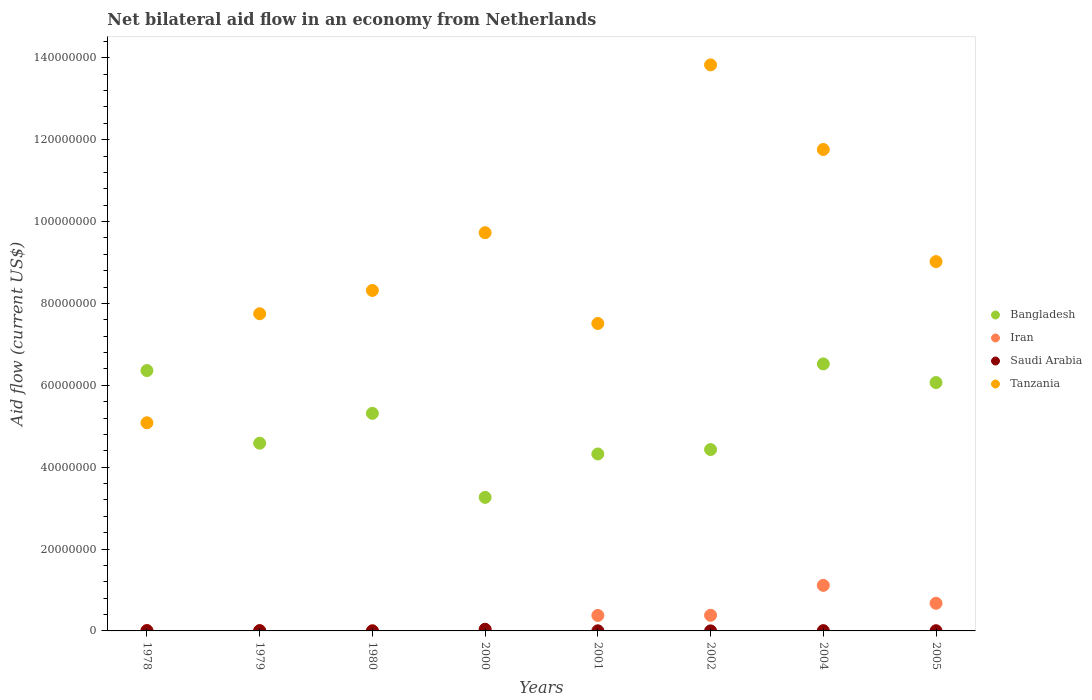How many different coloured dotlines are there?
Offer a very short reply. 4. What is the net bilateral aid flow in Bangladesh in 2002?
Provide a succinct answer. 4.43e+07. Across all years, what is the maximum net bilateral aid flow in Iran?
Make the answer very short. 1.11e+07. Across all years, what is the minimum net bilateral aid flow in Saudi Arabia?
Give a very brief answer. 10000. In which year was the net bilateral aid flow in Iran maximum?
Provide a short and direct response. 2004. In which year was the net bilateral aid flow in Tanzania minimum?
Provide a short and direct response. 1978. What is the total net bilateral aid flow in Bangladesh in the graph?
Provide a short and direct response. 4.09e+08. What is the difference between the net bilateral aid flow in Bangladesh in 1980 and that in 2002?
Offer a terse response. 8.85e+06. What is the difference between the net bilateral aid flow in Iran in 1979 and the net bilateral aid flow in Saudi Arabia in 1978?
Provide a succinct answer. -3.00e+04. What is the average net bilateral aid flow in Tanzania per year?
Your answer should be compact. 9.13e+07. In the year 2000, what is the difference between the net bilateral aid flow in Bangladesh and net bilateral aid flow in Tanzania?
Provide a succinct answer. -6.47e+07. What is the ratio of the net bilateral aid flow in Saudi Arabia in 1978 to that in 1980?
Provide a succinct answer. 3.5. Is the net bilateral aid flow in Bangladesh in 2000 less than that in 2004?
Your answer should be compact. Yes. Is the difference between the net bilateral aid flow in Bangladesh in 1979 and 1980 greater than the difference between the net bilateral aid flow in Tanzania in 1979 and 1980?
Provide a succinct answer. No. What is the difference between the highest and the second highest net bilateral aid flow in Saudi Arabia?
Provide a succinct answer. 3.40e+05. What is the difference between the highest and the lowest net bilateral aid flow in Bangladesh?
Offer a terse response. 3.26e+07. In how many years, is the net bilateral aid flow in Saudi Arabia greater than the average net bilateral aid flow in Saudi Arabia taken over all years?
Give a very brief answer. 1. Is it the case that in every year, the sum of the net bilateral aid flow in Iran and net bilateral aid flow in Tanzania  is greater than the sum of net bilateral aid flow in Bangladesh and net bilateral aid flow in Saudi Arabia?
Your response must be concise. No. Is it the case that in every year, the sum of the net bilateral aid flow in Bangladesh and net bilateral aid flow in Saudi Arabia  is greater than the net bilateral aid flow in Iran?
Keep it short and to the point. Yes. Does the net bilateral aid flow in Tanzania monotonically increase over the years?
Your answer should be compact. No. How many dotlines are there?
Keep it short and to the point. 4. How many years are there in the graph?
Offer a terse response. 8. Does the graph contain any zero values?
Your response must be concise. No. Does the graph contain grids?
Your answer should be very brief. No. How many legend labels are there?
Keep it short and to the point. 4. How are the legend labels stacked?
Offer a very short reply. Vertical. What is the title of the graph?
Your answer should be compact. Net bilateral aid flow in an economy from Netherlands. What is the label or title of the X-axis?
Offer a terse response. Years. What is the Aid flow (current US$) of Bangladesh in 1978?
Offer a very short reply. 6.36e+07. What is the Aid flow (current US$) of Saudi Arabia in 1978?
Make the answer very short. 7.00e+04. What is the Aid flow (current US$) of Tanzania in 1978?
Your answer should be very brief. 5.08e+07. What is the Aid flow (current US$) in Bangladesh in 1979?
Keep it short and to the point. 4.59e+07. What is the Aid flow (current US$) of Tanzania in 1979?
Ensure brevity in your answer.  7.75e+07. What is the Aid flow (current US$) of Bangladesh in 1980?
Your answer should be very brief. 5.32e+07. What is the Aid flow (current US$) of Iran in 1980?
Provide a succinct answer. 10000. What is the Aid flow (current US$) in Tanzania in 1980?
Make the answer very short. 8.32e+07. What is the Aid flow (current US$) in Bangladesh in 2000?
Your answer should be very brief. 3.26e+07. What is the Aid flow (current US$) of Saudi Arabia in 2000?
Provide a succinct answer. 4.10e+05. What is the Aid flow (current US$) in Tanzania in 2000?
Ensure brevity in your answer.  9.73e+07. What is the Aid flow (current US$) in Bangladesh in 2001?
Ensure brevity in your answer.  4.32e+07. What is the Aid flow (current US$) in Iran in 2001?
Give a very brief answer. 3.78e+06. What is the Aid flow (current US$) of Saudi Arabia in 2001?
Your response must be concise. 3.00e+04. What is the Aid flow (current US$) in Tanzania in 2001?
Make the answer very short. 7.51e+07. What is the Aid flow (current US$) in Bangladesh in 2002?
Keep it short and to the point. 4.43e+07. What is the Aid flow (current US$) in Iran in 2002?
Provide a short and direct response. 3.82e+06. What is the Aid flow (current US$) in Tanzania in 2002?
Give a very brief answer. 1.38e+08. What is the Aid flow (current US$) of Bangladesh in 2004?
Your answer should be compact. 6.52e+07. What is the Aid flow (current US$) in Iran in 2004?
Make the answer very short. 1.11e+07. What is the Aid flow (current US$) in Saudi Arabia in 2004?
Make the answer very short. 7.00e+04. What is the Aid flow (current US$) in Tanzania in 2004?
Your response must be concise. 1.18e+08. What is the Aid flow (current US$) in Bangladesh in 2005?
Provide a short and direct response. 6.07e+07. What is the Aid flow (current US$) of Iran in 2005?
Your response must be concise. 6.75e+06. What is the Aid flow (current US$) of Tanzania in 2005?
Offer a terse response. 9.02e+07. Across all years, what is the maximum Aid flow (current US$) in Bangladesh?
Offer a terse response. 6.52e+07. Across all years, what is the maximum Aid flow (current US$) in Iran?
Offer a terse response. 1.11e+07. Across all years, what is the maximum Aid flow (current US$) in Saudi Arabia?
Offer a terse response. 4.10e+05. Across all years, what is the maximum Aid flow (current US$) in Tanzania?
Keep it short and to the point. 1.38e+08. Across all years, what is the minimum Aid flow (current US$) of Bangladesh?
Your answer should be very brief. 3.26e+07. Across all years, what is the minimum Aid flow (current US$) of Iran?
Provide a short and direct response. 10000. Across all years, what is the minimum Aid flow (current US$) of Saudi Arabia?
Offer a very short reply. 10000. Across all years, what is the minimum Aid flow (current US$) of Tanzania?
Keep it short and to the point. 5.08e+07. What is the total Aid flow (current US$) in Bangladesh in the graph?
Provide a succinct answer. 4.09e+08. What is the total Aid flow (current US$) of Iran in the graph?
Your response must be concise. 2.57e+07. What is the total Aid flow (current US$) in Saudi Arabia in the graph?
Provide a succinct answer. 7.30e+05. What is the total Aid flow (current US$) in Tanzania in the graph?
Your answer should be very brief. 7.30e+08. What is the difference between the Aid flow (current US$) in Bangladesh in 1978 and that in 1979?
Your answer should be very brief. 1.78e+07. What is the difference between the Aid flow (current US$) in Saudi Arabia in 1978 and that in 1979?
Your answer should be very brief. 0. What is the difference between the Aid flow (current US$) in Tanzania in 1978 and that in 1979?
Offer a terse response. -2.66e+07. What is the difference between the Aid flow (current US$) in Bangladesh in 1978 and that in 1980?
Your response must be concise. 1.04e+07. What is the difference between the Aid flow (current US$) of Saudi Arabia in 1978 and that in 1980?
Make the answer very short. 5.00e+04. What is the difference between the Aid flow (current US$) in Tanzania in 1978 and that in 1980?
Provide a succinct answer. -3.23e+07. What is the difference between the Aid flow (current US$) in Bangladesh in 1978 and that in 2000?
Provide a succinct answer. 3.10e+07. What is the difference between the Aid flow (current US$) in Tanzania in 1978 and that in 2000?
Your response must be concise. -4.64e+07. What is the difference between the Aid flow (current US$) in Bangladesh in 1978 and that in 2001?
Your response must be concise. 2.04e+07. What is the difference between the Aid flow (current US$) in Iran in 1978 and that in 2001?
Offer a very short reply. -3.71e+06. What is the difference between the Aid flow (current US$) of Saudi Arabia in 1978 and that in 2001?
Offer a terse response. 4.00e+04. What is the difference between the Aid flow (current US$) of Tanzania in 1978 and that in 2001?
Offer a very short reply. -2.43e+07. What is the difference between the Aid flow (current US$) of Bangladesh in 1978 and that in 2002?
Your response must be concise. 1.93e+07. What is the difference between the Aid flow (current US$) of Iran in 1978 and that in 2002?
Make the answer very short. -3.75e+06. What is the difference between the Aid flow (current US$) of Saudi Arabia in 1978 and that in 2002?
Provide a short and direct response. 6.00e+04. What is the difference between the Aid flow (current US$) in Tanzania in 1978 and that in 2002?
Provide a succinct answer. -8.74e+07. What is the difference between the Aid flow (current US$) of Bangladesh in 1978 and that in 2004?
Your answer should be very brief. -1.62e+06. What is the difference between the Aid flow (current US$) in Iran in 1978 and that in 2004?
Give a very brief answer. -1.11e+07. What is the difference between the Aid flow (current US$) in Tanzania in 1978 and that in 2004?
Your response must be concise. -6.68e+07. What is the difference between the Aid flow (current US$) of Bangladesh in 1978 and that in 2005?
Provide a succinct answer. 2.93e+06. What is the difference between the Aid flow (current US$) in Iran in 1978 and that in 2005?
Provide a short and direct response. -6.68e+06. What is the difference between the Aid flow (current US$) in Tanzania in 1978 and that in 2005?
Give a very brief answer. -3.94e+07. What is the difference between the Aid flow (current US$) in Bangladesh in 1979 and that in 1980?
Your answer should be compact. -7.30e+06. What is the difference between the Aid flow (current US$) in Tanzania in 1979 and that in 1980?
Offer a very short reply. -5.69e+06. What is the difference between the Aid flow (current US$) in Bangladesh in 1979 and that in 2000?
Your response must be concise. 1.32e+07. What is the difference between the Aid flow (current US$) of Iran in 1979 and that in 2000?
Your answer should be very brief. -3.00e+04. What is the difference between the Aid flow (current US$) in Saudi Arabia in 1979 and that in 2000?
Your response must be concise. -3.40e+05. What is the difference between the Aid flow (current US$) of Tanzania in 1979 and that in 2000?
Ensure brevity in your answer.  -1.98e+07. What is the difference between the Aid flow (current US$) in Bangladesh in 1979 and that in 2001?
Provide a short and direct response. 2.63e+06. What is the difference between the Aid flow (current US$) of Iran in 1979 and that in 2001?
Offer a very short reply. -3.74e+06. What is the difference between the Aid flow (current US$) in Tanzania in 1979 and that in 2001?
Ensure brevity in your answer.  2.38e+06. What is the difference between the Aid flow (current US$) of Bangladesh in 1979 and that in 2002?
Offer a very short reply. 1.55e+06. What is the difference between the Aid flow (current US$) in Iran in 1979 and that in 2002?
Your answer should be very brief. -3.78e+06. What is the difference between the Aid flow (current US$) of Tanzania in 1979 and that in 2002?
Your response must be concise. -6.08e+07. What is the difference between the Aid flow (current US$) in Bangladesh in 1979 and that in 2004?
Keep it short and to the point. -1.94e+07. What is the difference between the Aid flow (current US$) of Iran in 1979 and that in 2004?
Your response must be concise. -1.11e+07. What is the difference between the Aid flow (current US$) in Tanzania in 1979 and that in 2004?
Your answer should be compact. -4.01e+07. What is the difference between the Aid flow (current US$) of Bangladesh in 1979 and that in 2005?
Provide a succinct answer. -1.48e+07. What is the difference between the Aid flow (current US$) in Iran in 1979 and that in 2005?
Make the answer very short. -6.71e+06. What is the difference between the Aid flow (current US$) of Tanzania in 1979 and that in 2005?
Your response must be concise. -1.27e+07. What is the difference between the Aid flow (current US$) in Bangladesh in 1980 and that in 2000?
Your answer should be compact. 2.05e+07. What is the difference between the Aid flow (current US$) of Iran in 1980 and that in 2000?
Your response must be concise. -6.00e+04. What is the difference between the Aid flow (current US$) in Saudi Arabia in 1980 and that in 2000?
Provide a succinct answer. -3.90e+05. What is the difference between the Aid flow (current US$) in Tanzania in 1980 and that in 2000?
Provide a short and direct response. -1.41e+07. What is the difference between the Aid flow (current US$) of Bangladesh in 1980 and that in 2001?
Offer a terse response. 9.93e+06. What is the difference between the Aid flow (current US$) of Iran in 1980 and that in 2001?
Your response must be concise. -3.77e+06. What is the difference between the Aid flow (current US$) in Tanzania in 1980 and that in 2001?
Give a very brief answer. 8.07e+06. What is the difference between the Aid flow (current US$) of Bangladesh in 1980 and that in 2002?
Ensure brevity in your answer.  8.85e+06. What is the difference between the Aid flow (current US$) of Iran in 1980 and that in 2002?
Your answer should be compact. -3.81e+06. What is the difference between the Aid flow (current US$) in Tanzania in 1980 and that in 2002?
Make the answer very short. -5.51e+07. What is the difference between the Aid flow (current US$) of Bangladesh in 1980 and that in 2004?
Provide a succinct answer. -1.21e+07. What is the difference between the Aid flow (current US$) of Iran in 1980 and that in 2004?
Offer a very short reply. -1.11e+07. What is the difference between the Aid flow (current US$) of Saudi Arabia in 1980 and that in 2004?
Your answer should be compact. -5.00e+04. What is the difference between the Aid flow (current US$) in Tanzania in 1980 and that in 2004?
Provide a short and direct response. -3.44e+07. What is the difference between the Aid flow (current US$) of Bangladesh in 1980 and that in 2005?
Offer a terse response. -7.52e+06. What is the difference between the Aid flow (current US$) of Iran in 1980 and that in 2005?
Offer a very short reply. -6.74e+06. What is the difference between the Aid flow (current US$) in Saudi Arabia in 1980 and that in 2005?
Offer a terse response. -3.00e+04. What is the difference between the Aid flow (current US$) in Tanzania in 1980 and that in 2005?
Your answer should be compact. -7.05e+06. What is the difference between the Aid flow (current US$) of Bangladesh in 2000 and that in 2001?
Offer a terse response. -1.06e+07. What is the difference between the Aid flow (current US$) of Iran in 2000 and that in 2001?
Your response must be concise. -3.71e+06. What is the difference between the Aid flow (current US$) in Tanzania in 2000 and that in 2001?
Your answer should be very brief. 2.22e+07. What is the difference between the Aid flow (current US$) of Bangladesh in 2000 and that in 2002?
Your answer should be compact. -1.17e+07. What is the difference between the Aid flow (current US$) of Iran in 2000 and that in 2002?
Make the answer very short. -3.75e+06. What is the difference between the Aid flow (current US$) of Saudi Arabia in 2000 and that in 2002?
Your answer should be very brief. 4.00e+05. What is the difference between the Aid flow (current US$) of Tanzania in 2000 and that in 2002?
Ensure brevity in your answer.  -4.10e+07. What is the difference between the Aid flow (current US$) of Bangladesh in 2000 and that in 2004?
Keep it short and to the point. -3.26e+07. What is the difference between the Aid flow (current US$) in Iran in 2000 and that in 2004?
Ensure brevity in your answer.  -1.11e+07. What is the difference between the Aid flow (current US$) of Saudi Arabia in 2000 and that in 2004?
Provide a succinct answer. 3.40e+05. What is the difference between the Aid flow (current US$) of Tanzania in 2000 and that in 2004?
Provide a succinct answer. -2.03e+07. What is the difference between the Aid flow (current US$) in Bangladesh in 2000 and that in 2005?
Offer a very short reply. -2.80e+07. What is the difference between the Aid flow (current US$) in Iran in 2000 and that in 2005?
Your response must be concise. -6.68e+06. What is the difference between the Aid flow (current US$) in Saudi Arabia in 2000 and that in 2005?
Give a very brief answer. 3.60e+05. What is the difference between the Aid flow (current US$) in Tanzania in 2000 and that in 2005?
Ensure brevity in your answer.  7.06e+06. What is the difference between the Aid flow (current US$) in Bangladesh in 2001 and that in 2002?
Your answer should be very brief. -1.08e+06. What is the difference between the Aid flow (current US$) of Tanzania in 2001 and that in 2002?
Ensure brevity in your answer.  -6.32e+07. What is the difference between the Aid flow (current US$) of Bangladesh in 2001 and that in 2004?
Make the answer very short. -2.20e+07. What is the difference between the Aid flow (current US$) of Iran in 2001 and that in 2004?
Keep it short and to the point. -7.35e+06. What is the difference between the Aid flow (current US$) of Tanzania in 2001 and that in 2004?
Make the answer very short. -4.25e+07. What is the difference between the Aid flow (current US$) in Bangladesh in 2001 and that in 2005?
Your response must be concise. -1.74e+07. What is the difference between the Aid flow (current US$) of Iran in 2001 and that in 2005?
Keep it short and to the point. -2.97e+06. What is the difference between the Aid flow (current US$) in Saudi Arabia in 2001 and that in 2005?
Offer a very short reply. -2.00e+04. What is the difference between the Aid flow (current US$) of Tanzania in 2001 and that in 2005?
Your answer should be very brief. -1.51e+07. What is the difference between the Aid flow (current US$) in Bangladesh in 2002 and that in 2004?
Make the answer very short. -2.09e+07. What is the difference between the Aid flow (current US$) of Iran in 2002 and that in 2004?
Your answer should be compact. -7.31e+06. What is the difference between the Aid flow (current US$) of Saudi Arabia in 2002 and that in 2004?
Ensure brevity in your answer.  -6.00e+04. What is the difference between the Aid flow (current US$) of Tanzania in 2002 and that in 2004?
Provide a short and direct response. 2.07e+07. What is the difference between the Aid flow (current US$) of Bangladesh in 2002 and that in 2005?
Your answer should be very brief. -1.64e+07. What is the difference between the Aid flow (current US$) of Iran in 2002 and that in 2005?
Give a very brief answer. -2.93e+06. What is the difference between the Aid flow (current US$) in Tanzania in 2002 and that in 2005?
Your answer should be compact. 4.81e+07. What is the difference between the Aid flow (current US$) in Bangladesh in 2004 and that in 2005?
Your answer should be compact. 4.55e+06. What is the difference between the Aid flow (current US$) of Iran in 2004 and that in 2005?
Your response must be concise. 4.38e+06. What is the difference between the Aid flow (current US$) of Tanzania in 2004 and that in 2005?
Make the answer very short. 2.74e+07. What is the difference between the Aid flow (current US$) of Bangladesh in 1978 and the Aid flow (current US$) of Iran in 1979?
Offer a terse response. 6.36e+07. What is the difference between the Aid flow (current US$) in Bangladesh in 1978 and the Aid flow (current US$) in Saudi Arabia in 1979?
Your answer should be compact. 6.35e+07. What is the difference between the Aid flow (current US$) of Bangladesh in 1978 and the Aid flow (current US$) of Tanzania in 1979?
Make the answer very short. -1.39e+07. What is the difference between the Aid flow (current US$) of Iran in 1978 and the Aid flow (current US$) of Tanzania in 1979?
Your answer should be compact. -7.74e+07. What is the difference between the Aid flow (current US$) of Saudi Arabia in 1978 and the Aid flow (current US$) of Tanzania in 1979?
Offer a very short reply. -7.74e+07. What is the difference between the Aid flow (current US$) in Bangladesh in 1978 and the Aid flow (current US$) in Iran in 1980?
Give a very brief answer. 6.36e+07. What is the difference between the Aid flow (current US$) in Bangladesh in 1978 and the Aid flow (current US$) in Saudi Arabia in 1980?
Provide a short and direct response. 6.36e+07. What is the difference between the Aid flow (current US$) in Bangladesh in 1978 and the Aid flow (current US$) in Tanzania in 1980?
Your answer should be very brief. -1.96e+07. What is the difference between the Aid flow (current US$) of Iran in 1978 and the Aid flow (current US$) of Tanzania in 1980?
Provide a succinct answer. -8.31e+07. What is the difference between the Aid flow (current US$) in Saudi Arabia in 1978 and the Aid flow (current US$) in Tanzania in 1980?
Make the answer very short. -8.31e+07. What is the difference between the Aid flow (current US$) in Bangladesh in 1978 and the Aid flow (current US$) in Iran in 2000?
Keep it short and to the point. 6.35e+07. What is the difference between the Aid flow (current US$) in Bangladesh in 1978 and the Aid flow (current US$) in Saudi Arabia in 2000?
Ensure brevity in your answer.  6.32e+07. What is the difference between the Aid flow (current US$) in Bangladesh in 1978 and the Aid flow (current US$) in Tanzania in 2000?
Your answer should be compact. -3.37e+07. What is the difference between the Aid flow (current US$) of Iran in 1978 and the Aid flow (current US$) of Tanzania in 2000?
Your answer should be compact. -9.72e+07. What is the difference between the Aid flow (current US$) in Saudi Arabia in 1978 and the Aid flow (current US$) in Tanzania in 2000?
Offer a very short reply. -9.72e+07. What is the difference between the Aid flow (current US$) of Bangladesh in 1978 and the Aid flow (current US$) of Iran in 2001?
Ensure brevity in your answer.  5.98e+07. What is the difference between the Aid flow (current US$) of Bangladesh in 1978 and the Aid flow (current US$) of Saudi Arabia in 2001?
Make the answer very short. 6.36e+07. What is the difference between the Aid flow (current US$) in Bangladesh in 1978 and the Aid flow (current US$) in Tanzania in 2001?
Offer a very short reply. -1.15e+07. What is the difference between the Aid flow (current US$) in Iran in 1978 and the Aid flow (current US$) in Tanzania in 2001?
Give a very brief answer. -7.50e+07. What is the difference between the Aid flow (current US$) in Saudi Arabia in 1978 and the Aid flow (current US$) in Tanzania in 2001?
Your answer should be compact. -7.50e+07. What is the difference between the Aid flow (current US$) in Bangladesh in 1978 and the Aid flow (current US$) in Iran in 2002?
Make the answer very short. 5.98e+07. What is the difference between the Aid flow (current US$) in Bangladesh in 1978 and the Aid flow (current US$) in Saudi Arabia in 2002?
Give a very brief answer. 6.36e+07. What is the difference between the Aid flow (current US$) of Bangladesh in 1978 and the Aid flow (current US$) of Tanzania in 2002?
Ensure brevity in your answer.  -7.47e+07. What is the difference between the Aid flow (current US$) in Iran in 1978 and the Aid flow (current US$) in Saudi Arabia in 2002?
Give a very brief answer. 6.00e+04. What is the difference between the Aid flow (current US$) in Iran in 1978 and the Aid flow (current US$) in Tanzania in 2002?
Keep it short and to the point. -1.38e+08. What is the difference between the Aid flow (current US$) in Saudi Arabia in 1978 and the Aid flow (current US$) in Tanzania in 2002?
Provide a succinct answer. -1.38e+08. What is the difference between the Aid flow (current US$) of Bangladesh in 1978 and the Aid flow (current US$) of Iran in 2004?
Keep it short and to the point. 5.25e+07. What is the difference between the Aid flow (current US$) in Bangladesh in 1978 and the Aid flow (current US$) in Saudi Arabia in 2004?
Keep it short and to the point. 6.35e+07. What is the difference between the Aid flow (current US$) of Bangladesh in 1978 and the Aid flow (current US$) of Tanzania in 2004?
Keep it short and to the point. -5.40e+07. What is the difference between the Aid flow (current US$) of Iran in 1978 and the Aid flow (current US$) of Saudi Arabia in 2004?
Your answer should be very brief. 0. What is the difference between the Aid flow (current US$) in Iran in 1978 and the Aid flow (current US$) in Tanzania in 2004?
Your answer should be very brief. -1.18e+08. What is the difference between the Aid flow (current US$) of Saudi Arabia in 1978 and the Aid flow (current US$) of Tanzania in 2004?
Give a very brief answer. -1.18e+08. What is the difference between the Aid flow (current US$) in Bangladesh in 1978 and the Aid flow (current US$) in Iran in 2005?
Give a very brief answer. 5.69e+07. What is the difference between the Aid flow (current US$) in Bangladesh in 1978 and the Aid flow (current US$) in Saudi Arabia in 2005?
Provide a succinct answer. 6.36e+07. What is the difference between the Aid flow (current US$) in Bangladesh in 1978 and the Aid flow (current US$) in Tanzania in 2005?
Offer a very short reply. -2.66e+07. What is the difference between the Aid flow (current US$) in Iran in 1978 and the Aid flow (current US$) in Tanzania in 2005?
Offer a very short reply. -9.02e+07. What is the difference between the Aid flow (current US$) in Saudi Arabia in 1978 and the Aid flow (current US$) in Tanzania in 2005?
Provide a succinct answer. -9.02e+07. What is the difference between the Aid flow (current US$) of Bangladesh in 1979 and the Aid flow (current US$) of Iran in 1980?
Provide a succinct answer. 4.58e+07. What is the difference between the Aid flow (current US$) in Bangladesh in 1979 and the Aid flow (current US$) in Saudi Arabia in 1980?
Offer a terse response. 4.58e+07. What is the difference between the Aid flow (current US$) of Bangladesh in 1979 and the Aid flow (current US$) of Tanzania in 1980?
Give a very brief answer. -3.73e+07. What is the difference between the Aid flow (current US$) in Iran in 1979 and the Aid flow (current US$) in Tanzania in 1980?
Offer a very short reply. -8.31e+07. What is the difference between the Aid flow (current US$) in Saudi Arabia in 1979 and the Aid flow (current US$) in Tanzania in 1980?
Your answer should be compact. -8.31e+07. What is the difference between the Aid flow (current US$) of Bangladesh in 1979 and the Aid flow (current US$) of Iran in 2000?
Your answer should be compact. 4.58e+07. What is the difference between the Aid flow (current US$) in Bangladesh in 1979 and the Aid flow (current US$) in Saudi Arabia in 2000?
Provide a succinct answer. 4.54e+07. What is the difference between the Aid flow (current US$) of Bangladesh in 1979 and the Aid flow (current US$) of Tanzania in 2000?
Ensure brevity in your answer.  -5.14e+07. What is the difference between the Aid flow (current US$) in Iran in 1979 and the Aid flow (current US$) in Saudi Arabia in 2000?
Provide a succinct answer. -3.70e+05. What is the difference between the Aid flow (current US$) in Iran in 1979 and the Aid flow (current US$) in Tanzania in 2000?
Your answer should be compact. -9.72e+07. What is the difference between the Aid flow (current US$) in Saudi Arabia in 1979 and the Aid flow (current US$) in Tanzania in 2000?
Ensure brevity in your answer.  -9.72e+07. What is the difference between the Aid flow (current US$) of Bangladesh in 1979 and the Aid flow (current US$) of Iran in 2001?
Offer a terse response. 4.21e+07. What is the difference between the Aid flow (current US$) in Bangladesh in 1979 and the Aid flow (current US$) in Saudi Arabia in 2001?
Your response must be concise. 4.58e+07. What is the difference between the Aid flow (current US$) in Bangladesh in 1979 and the Aid flow (current US$) in Tanzania in 2001?
Give a very brief answer. -2.92e+07. What is the difference between the Aid flow (current US$) in Iran in 1979 and the Aid flow (current US$) in Tanzania in 2001?
Provide a succinct answer. -7.51e+07. What is the difference between the Aid flow (current US$) of Saudi Arabia in 1979 and the Aid flow (current US$) of Tanzania in 2001?
Keep it short and to the point. -7.50e+07. What is the difference between the Aid flow (current US$) in Bangladesh in 1979 and the Aid flow (current US$) in Iran in 2002?
Make the answer very short. 4.20e+07. What is the difference between the Aid flow (current US$) in Bangladesh in 1979 and the Aid flow (current US$) in Saudi Arabia in 2002?
Provide a succinct answer. 4.58e+07. What is the difference between the Aid flow (current US$) in Bangladesh in 1979 and the Aid flow (current US$) in Tanzania in 2002?
Offer a very short reply. -9.24e+07. What is the difference between the Aid flow (current US$) in Iran in 1979 and the Aid flow (current US$) in Tanzania in 2002?
Keep it short and to the point. -1.38e+08. What is the difference between the Aid flow (current US$) of Saudi Arabia in 1979 and the Aid flow (current US$) of Tanzania in 2002?
Your answer should be compact. -1.38e+08. What is the difference between the Aid flow (current US$) in Bangladesh in 1979 and the Aid flow (current US$) in Iran in 2004?
Make the answer very short. 3.47e+07. What is the difference between the Aid flow (current US$) in Bangladesh in 1979 and the Aid flow (current US$) in Saudi Arabia in 2004?
Keep it short and to the point. 4.58e+07. What is the difference between the Aid flow (current US$) in Bangladesh in 1979 and the Aid flow (current US$) in Tanzania in 2004?
Your answer should be compact. -7.18e+07. What is the difference between the Aid flow (current US$) in Iran in 1979 and the Aid flow (current US$) in Saudi Arabia in 2004?
Provide a succinct answer. -3.00e+04. What is the difference between the Aid flow (current US$) in Iran in 1979 and the Aid flow (current US$) in Tanzania in 2004?
Keep it short and to the point. -1.18e+08. What is the difference between the Aid flow (current US$) in Saudi Arabia in 1979 and the Aid flow (current US$) in Tanzania in 2004?
Your response must be concise. -1.18e+08. What is the difference between the Aid flow (current US$) in Bangladesh in 1979 and the Aid flow (current US$) in Iran in 2005?
Your answer should be very brief. 3.91e+07. What is the difference between the Aid flow (current US$) in Bangladesh in 1979 and the Aid flow (current US$) in Saudi Arabia in 2005?
Your answer should be very brief. 4.58e+07. What is the difference between the Aid flow (current US$) in Bangladesh in 1979 and the Aid flow (current US$) in Tanzania in 2005?
Ensure brevity in your answer.  -4.44e+07. What is the difference between the Aid flow (current US$) of Iran in 1979 and the Aid flow (current US$) of Tanzania in 2005?
Keep it short and to the point. -9.02e+07. What is the difference between the Aid flow (current US$) in Saudi Arabia in 1979 and the Aid flow (current US$) in Tanzania in 2005?
Make the answer very short. -9.02e+07. What is the difference between the Aid flow (current US$) of Bangladesh in 1980 and the Aid flow (current US$) of Iran in 2000?
Your answer should be compact. 5.31e+07. What is the difference between the Aid flow (current US$) in Bangladesh in 1980 and the Aid flow (current US$) in Saudi Arabia in 2000?
Your answer should be compact. 5.28e+07. What is the difference between the Aid flow (current US$) of Bangladesh in 1980 and the Aid flow (current US$) of Tanzania in 2000?
Give a very brief answer. -4.41e+07. What is the difference between the Aid flow (current US$) in Iran in 1980 and the Aid flow (current US$) in Saudi Arabia in 2000?
Ensure brevity in your answer.  -4.00e+05. What is the difference between the Aid flow (current US$) in Iran in 1980 and the Aid flow (current US$) in Tanzania in 2000?
Your response must be concise. -9.73e+07. What is the difference between the Aid flow (current US$) of Saudi Arabia in 1980 and the Aid flow (current US$) of Tanzania in 2000?
Your response must be concise. -9.73e+07. What is the difference between the Aid flow (current US$) of Bangladesh in 1980 and the Aid flow (current US$) of Iran in 2001?
Ensure brevity in your answer.  4.94e+07. What is the difference between the Aid flow (current US$) of Bangladesh in 1980 and the Aid flow (current US$) of Saudi Arabia in 2001?
Your response must be concise. 5.31e+07. What is the difference between the Aid flow (current US$) of Bangladesh in 1980 and the Aid flow (current US$) of Tanzania in 2001?
Your answer should be compact. -2.20e+07. What is the difference between the Aid flow (current US$) in Iran in 1980 and the Aid flow (current US$) in Tanzania in 2001?
Provide a short and direct response. -7.51e+07. What is the difference between the Aid flow (current US$) of Saudi Arabia in 1980 and the Aid flow (current US$) of Tanzania in 2001?
Your answer should be compact. -7.51e+07. What is the difference between the Aid flow (current US$) in Bangladesh in 1980 and the Aid flow (current US$) in Iran in 2002?
Make the answer very short. 4.93e+07. What is the difference between the Aid flow (current US$) of Bangladesh in 1980 and the Aid flow (current US$) of Saudi Arabia in 2002?
Ensure brevity in your answer.  5.32e+07. What is the difference between the Aid flow (current US$) of Bangladesh in 1980 and the Aid flow (current US$) of Tanzania in 2002?
Offer a terse response. -8.51e+07. What is the difference between the Aid flow (current US$) of Iran in 1980 and the Aid flow (current US$) of Tanzania in 2002?
Keep it short and to the point. -1.38e+08. What is the difference between the Aid flow (current US$) in Saudi Arabia in 1980 and the Aid flow (current US$) in Tanzania in 2002?
Ensure brevity in your answer.  -1.38e+08. What is the difference between the Aid flow (current US$) in Bangladesh in 1980 and the Aid flow (current US$) in Iran in 2004?
Give a very brief answer. 4.20e+07. What is the difference between the Aid flow (current US$) in Bangladesh in 1980 and the Aid flow (current US$) in Saudi Arabia in 2004?
Provide a succinct answer. 5.31e+07. What is the difference between the Aid flow (current US$) in Bangladesh in 1980 and the Aid flow (current US$) in Tanzania in 2004?
Offer a terse response. -6.45e+07. What is the difference between the Aid flow (current US$) in Iran in 1980 and the Aid flow (current US$) in Saudi Arabia in 2004?
Provide a short and direct response. -6.00e+04. What is the difference between the Aid flow (current US$) in Iran in 1980 and the Aid flow (current US$) in Tanzania in 2004?
Your response must be concise. -1.18e+08. What is the difference between the Aid flow (current US$) in Saudi Arabia in 1980 and the Aid flow (current US$) in Tanzania in 2004?
Give a very brief answer. -1.18e+08. What is the difference between the Aid flow (current US$) of Bangladesh in 1980 and the Aid flow (current US$) of Iran in 2005?
Your answer should be compact. 4.64e+07. What is the difference between the Aid flow (current US$) of Bangladesh in 1980 and the Aid flow (current US$) of Saudi Arabia in 2005?
Offer a very short reply. 5.31e+07. What is the difference between the Aid flow (current US$) in Bangladesh in 1980 and the Aid flow (current US$) in Tanzania in 2005?
Provide a short and direct response. -3.71e+07. What is the difference between the Aid flow (current US$) in Iran in 1980 and the Aid flow (current US$) in Saudi Arabia in 2005?
Provide a short and direct response. -4.00e+04. What is the difference between the Aid flow (current US$) of Iran in 1980 and the Aid flow (current US$) of Tanzania in 2005?
Offer a terse response. -9.02e+07. What is the difference between the Aid flow (current US$) of Saudi Arabia in 1980 and the Aid flow (current US$) of Tanzania in 2005?
Offer a terse response. -9.02e+07. What is the difference between the Aid flow (current US$) of Bangladesh in 2000 and the Aid flow (current US$) of Iran in 2001?
Offer a very short reply. 2.88e+07. What is the difference between the Aid flow (current US$) of Bangladesh in 2000 and the Aid flow (current US$) of Saudi Arabia in 2001?
Ensure brevity in your answer.  3.26e+07. What is the difference between the Aid flow (current US$) in Bangladesh in 2000 and the Aid flow (current US$) in Tanzania in 2001?
Give a very brief answer. -4.25e+07. What is the difference between the Aid flow (current US$) in Iran in 2000 and the Aid flow (current US$) in Tanzania in 2001?
Offer a very short reply. -7.50e+07. What is the difference between the Aid flow (current US$) in Saudi Arabia in 2000 and the Aid flow (current US$) in Tanzania in 2001?
Give a very brief answer. -7.47e+07. What is the difference between the Aid flow (current US$) in Bangladesh in 2000 and the Aid flow (current US$) in Iran in 2002?
Your answer should be compact. 2.88e+07. What is the difference between the Aid flow (current US$) in Bangladesh in 2000 and the Aid flow (current US$) in Saudi Arabia in 2002?
Offer a terse response. 3.26e+07. What is the difference between the Aid flow (current US$) of Bangladesh in 2000 and the Aid flow (current US$) of Tanzania in 2002?
Keep it short and to the point. -1.06e+08. What is the difference between the Aid flow (current US$) of Iran in 2000 and the Aid flow (current US$) of Saudi Arabia in 2002?
Give a very brief answer. 6.00e+04. What is the difference between the Aid flow (current US$) of Iran in 2000 and the Aid flow (current US$) of Tanzania in 2002?
Offer a terse response. -1.38e+08. What is the difference between the Aid flow (current US$) of Saudi Arabia in 2000 and the Aid flow (current US$) of Tanzania in 2002?
Make the answer very short. -1.38e+08. What is the difference between the Aid flow (current US$) of Bangladesh in 2000 and the Aid flow (current US$) of Iran in 2004?
Ensure brevity in your answer.  2.15e+07. What is the difference between the Aid flow (current US$) of Bangladesh in 2000 and the Aid flow (current US$) of Saudi Arabia in 2004?
Provide a short and direct response. 3.26e+07. What is the difference between the Aid flow (current US$) in Bangladesh in 2000 and the Aid flow (current US$) in Tanzania in 2004?
Your answer should be very brief. -8.50e+07. What is the difference between the Aid flow (current US$) in Iran in 2000 and the Aid flow (current US$) in Saudi Arabia in 2004?
Give a very brief answer. 0. What is the difference between the Aid flow (current US$) in Iran in 2000 and the Aid flow (current US$) in Tanzania in 2004?
Your response must be concise. -1.18e+08. What is the difference between the Aid flow (current US$) in Saudi Arabia in 2000 and the Aid flow (current US$) in Tanzania in 2004?
Give a very brief answer. -1.17e+08. What is the difference between the Aid flow (current US$) in Bangladesh in 2000 and the Aid flow (current US$) in Iran in 2005?
Keep it short and to the point. 2.59e+07. What is the difference between the Aid flow (current US$) of Bangladesh in 2000 and the Aid flow (current US$) of Saudi Arabia in 2005?
Provide a short and direct response. 3.26e+07. What is the difference between the Aid flow (current US$) in Bangladesh in 2000 and the Aid flow (current US$) in Tanzania in 2005?
Make the answer very short. -5.76e+07. What is the difference between the Aid flow (current US$) of Iran in 2000 and the Aid flow (current US$) of Saudi Arabia in 2005?
Give a very brief answer. 2.00e+04. What is the difference between the Aid flow (current US$) in Iran in 2000 and the Aid flow (current US$) in Tanzania in 2005?
Offer a very short reply. -9.02e+07. What is the difference between the Aid flow (current US$) in Saudi Arabia in 2000 and the Aid flow (current US$) in Tanzania in 2005?
Make the answer very short. -8.98e+07. What is the difference between the Aid flow (current US$) in Bangladesh in 2001 and the Aid flow (current US$) in Iran in 2002?
Your answer should be compact. 3.94e+07. What is the difference between the Aid flow (current US$) in Bangladesh in 2001 and the Aid flow (current US$) in Saudi Arabia in 2002?
Offer a terse response. 4.32e+07. What is the difference between the Aid flow (current US$) of Bangladesh in 2001 and the Aid flow (current US$) of Tanzania in 2002?
Your response must be concise. -9.51e+07. What is the difference between the Aid flow (current US$) in Iran in 2001 and the Aid flow (current US$) in Saudi Arabia in 2002?
Give a very brief answer. 3.77e+06. What is the difference between the Aid flow (current US$) in Iran in 2001 and the Aid flow (current US$) in Tanzania in 2002?
Your answer should be very brief. -1.35e+08. What is the difference between the Aid flow (current US$) of Saudi Arabia in 2001 and the Aid flow (current US$) of Tanzania in 2002?
Provide a short and direct response. -1.38e+08. What is the difference between the Aid flow (current US$) in Bangladesh in 2001 and the Aid flow (current US$) in Iran in 2004?
Your answer should be very brief. 3.21e+07. What is the difference between the Aid flow (current US$) of Bangladesh in 2001 and the Aid flow (current US$) of Saudi Arabia in 2004?
Make the answer very short. 4.32e+07. What is the difference between the Aid flow (current US$) of Bangladesh in 2001 and the Aid flow (current US$) of Tanzania in 2004?
Make the answer very short. -7.44e+07. What is the difference between the Aid flow (current US$) of Iran in 2001 and the Aid flow (current US$) of Saudi Arabia in 2004?
Offer a terse response. 3.71e+06. What is the difference between the Aid flow (current US$) of Iran in 2001 and the Aid flow (current US$) of Tanzania in 2004?
Offer a very short reply. -1.14e+08. What is the difference between the Aid flow (current US$) of Saudi Arabia in 2001 and the Aid flow (current US$) of Tanzania in 2004?
Keep it short and to the point. -1.18e+08. What is the difference between the Aid flow (current US$) of Bangladesh in 2001 and the Aid flow (current US$) of Iran in 2005?
Make the answer very short. 3.65e+07. What is the difference between the Aid flow (current US$) in Bangladesh in 2001 and the Aid flow (current US$) in Saudi Arabia in 2005?
Your answer should be very brief. 4.32e+07. What is the difference between the Aid flow (current US$) in Bangladesh in 2001 and the Aid flow (current US$) in Tanzania in 2005?
Your answer should be compact. -4.70e+07. What is the difference between the Aid flow (current US$) in Iran in 2001 and the Aid flow (current US$) in Saudi Arabia in 2005?
Offer a terse response. 3.73e+06. What is the difference between the Aid flow (current US$) of Iran in 2001 and the Aid flow (current US$) of Tanzania in 2005?
Ensure brevity in your answer.  -8.64e+07. What is the difference between the Aid flow (current US$) of Saudi Arabia in 2001 and the Aid flow (current US$) of Tanzania in 2005?
Offer a very short reply. -9.02e+07. What is the difference between the Aid flow (current US$) of Bangladesh in 2002 and the Aid flow (current US$) of Iran in 2004?
Give a very brief answer. 3.32e+07. What is the difference between the Aid flow (current US$) in Bangladesh in 2002 and the Aid flow (current US$) in Saudi Arabia in 2004?
Your answer should be very brief. 4.42e+07. What is the difference between the Aid flow (current US$) of Bangladesh in 2002 and the Aid flow (current US$) of Tanzania in 2004?
Your answer should be compact. -7.33e+07. What is the difference between the Aid flow (current US$) in Iran in 2002 and the Aid flow (current US$) in Saudi Arabia in 2004?
Your response must be concise. 3.75e+06. What is the difference between the Aid flow (current US$) of Iran in 2002 and the Aid flow (current US$) of Tanzania in 2004?
Offer a very short reply. -1.14e+08. What is the difference between the Aid flow (current US$) in Saudi Arabia in 2002 and the Aid flow (current US$) in Tanzania in 2004?
Your answer should be very brief. -1.18e+08. What is the difference between the Aid flow (current US$) of Bangladesh in 2002 and the Aid flow (current US$) of Iran in 2005?
Offer a very short reply. 3.76e+07. What is the difference between the Aid flow (current US$) in Bangladesh in 2002 and the Aid flow (current US$) in Saudi Arabia in 2005?
Make the answer very short. 4.43e+07. What is the difference between the Aid flow (current US$) in Bangladesh in 2002 and the Aid flow (current US$) in Tanzania in 2005?
Offer a very short reply. -4.59e+07. What is the difference between the Aid flow (current US$) of Iran in 2002 and the Aid flow (current US$) of Saudi Arabia in 2005?
Ensure brevity in your answer.  3.77e+06. What is the difference between the Aid flow (current US$) in Iran in 2002 and the Aid flow (current US$) in Tanzania in 2005?
Make the answer very short. -8.64e+07. What is the difference between the Aid flow (current US$) of Saudi Arabia in 2002 and the Aid flow (current US$) of Tanzania in 2005?
Your answer should be compact. -9.02e+07. What is the difference between the Aid flow (current US$) of Bangladesh in 2004 and the Aid flow (current US$) of Iran in 2005?
Offer a terse response. 5.85e+07. What is the difference between the Aid flow (current US$) of Bangladesh in 2004 and the Aid flow (current US$) of Saudi Arabia in 2005?
Your response must be concise. 6.52e+07. What is the difference between the Aid flow (current US$) in Bangladesh in 2004 and the Aid flow (current US$) in Tanzania in 2005?
Provide a short and direct response. -2.50e+07. What is the difference between the Aid flow (current US$) in Iran in 2004 and the Aid flow (current US$) in Saudi Arabia in 2005?
Ensure brevity in your answer.  1.11e+07. What is the difference between the Aid flow (current US$) of Iran in 2004 and the Aid flow (current US$) of Tanzania in 2005?
Make the answer very short. -7.91e+07. What is the difference between the Aid flow (current US$) in Saudi Arabia in 2004 and the Aid flow (current US$) in Tanzania in 2005?
Your answer should be very brief. -9.02e+07. What is the average Aid flow (current US$) in Bangladesh per year?
Your response must be concise. 5.11e+07. What is the average Aid flow (current US$) in Iran per year?
Give a very brief answer. 3.21e+06. What is the average Aid flow (current US$) in Saudi Arabia per year?
Provide a succinct answer. 9.12e+04. What is the average Aid flow (current US$) in Tanzania per year?
Your answer should be very brief. 9.13e+07. In the year 1978, what is the difference between the Aid flow (current US$) in Bangladesh and Aid flow (current US$) in Iran?
Your response must be concise. 6.35e+07. In the year 1978, what is the difference between the Aid flow (current US$) of Bangladesh and Aid flow (current US$) of Saudi Arabia?
Give a very brief answer. 6.35e+07. In the year 1978, what is the difference between the Aid flow (current US$) of Bangladesh and Aid flow (current US$) of Tanzania?
Your response must be concise. 1.28e+07. In the year 1978, what is the difference between the Aid flow (current US$) of Iran and Aid flow (current US$) of Saudi Arabia?
Provide a succinct answer. 0. In the year 1978, what is the difference between the Aid flow (current US$) of Iran and Aid flow (current US$) of Tanzania?
Provide a succinct answer. -5.08e+07. In the year 1978, what is the difference between the Aid flow (current US$) of Saudi Arabia and Aid flow (current US$) of Tanzania?
Provide a short and direct response. -5.08e+07. In the year 1979, what is the difference between the Aid flow (current US$) of Bangladesh and Aid flow (current US$) of Iran?
Your answer should be very brief. 4.58e+07. In the year 1979, what is the difference between the Aid flow (current US$) in Bangladesh and Aid flow (current US$) in Saudi Arabia?
Make the answer very short. 4.58e+07. In the year 1979, what is the difference between the Aid flow (current US$) in Bangladesh and Aid flow (current US$) in Tanzania?
Give a very brief answer. -3.16e+07. In the year 1979, what is the difference between the Aid flow (current US$) in Iran and Aid flow (current US$) in Saudi Arabia?
Your response must be concise. -3.00e+04. In the year 1979, what is the difference between the Aid flow (current US$) of Iran and Aid flow (current US$) of Tanzania?
Offer a very short reply. -7.74e+07. In the year 1979, what is the difference between the Aid flow (current US$) in Saudi Arabia and Aid flow (current US$) in Tanzania?
Provide a succinct answer. -7.74e+07. In the year 1980, what is the difference between the Aid flow (current US$) of Bangladesh and Aid flow (current US$) of Iran?
Your response must be concise. 5.32e+07. In the year 1980, what is the difference between the Aid flow (current US$) in Bangladesh and Aid flow (current US$) in Saudi Arabia?
Make the answer very short. 5.31e+07. In the year 1980, what is the difference between the Aid flow (current US$) of Bangladesh and Aid flow (current US$) of Tanzania?
Keep it short and to the point. -3.00e+07. In the year 1980, what is the difference between the Aid flow (current US$) in Iran and Aid flow (current US$) in Tanzania?
Your answer should be very brief. -8.32e+07. In the year 1980, what is the difference between the Aid flow (current US$) of Saudi Arabia and Aid flow (current US$) of Tanzania?
Provide a succinct answer. -8.32e+07. In the year 2000, what is the difference between the Aid flow (current US$) in Bangladesh and Aid flow (current US$) in Iran?
Provide a succinct answer. 3.26e+07. In the year 2000, what is the difference between the Aid flow (current US$) of Bangladesh and Aid flow (current US$) of Saudi Arabia?
Make the answer very short. 3.22e+07. In the year 2000, what is the difference between the Aid flow (current US$) of Bangladesh and Aid flow (current US$) of Tanzania?
Give a very brief answer. -6.47e+07. In the year 2000, what is the difference between the Aid flow (current US$) of Iran and Aid flow (current US$) of Saudi Arabia?
Your answer should be very brief. -3.40e+05. In the year 2000, what is the difference between the Aid flow (current US$) in Iran and Aid flow (current US$) in Tanzania?
Offer a terse response. -9.72e+07. In the year 2000, what is the difference between the Aid flow (current US$) of Saudi Arabia and Aid flow (current US$) of Tanzania?
Provide a short and direct response. -9.69e+07. In the year 2001, what is the difference between the Aid flow (current US$) of Bangladesh and Aid flow (current US$) of Iran?
Keep it short and to the point. 3.94e+07. In the year 2001, what is the difference between the Aid flow (current US$) of Bangladesh and Aid flow (current US$) of Saudi Arabia?
Keep it short and to the point. 4.32e+07. In the year 2001, what is the difference between the Aid flow (current US$) of Bangladesh and Aid flow (current US$) of Tanzania?
Ensure brevity in your answer.  -3.19e+07. In the year 2001, what is the difference between the Aid flow (current US$) of Iran and Aid flow (current US$) of Saudi Arabia?
Give a very brief answer. 3.75e+06. In the year 2001, what is the difference between the Aid flow (current US$) of Iran and Aid flow (current US$) of Tanzania?
Give a very brief answer. -7.13e+07. In the year 2001, what is the difference between the Aid flow (current US$) of Saudi Arabia and Aid flow (current US$) of Tanzania?
Provide a short and direct response. -7.51e+07. In the year 2002, what is the difference between the Aid flow (current US$) of Bangladesh and Aid flow (current US$) of Iran?
Provide a short and direct response. 4.05e+07. In the year 2002, what is the difference between the Aid flow (current US$) in Bangladesh and Aid flow (current US$) in Saudi Arabia?
Ensure brevity in your answer.  4.43e+07. In the year 2002, what is the difference between the Aid flow (current US$) in Bangladesh and Aid flow (current US$) in Tanzania?
Offer a terse response. -9.40e+07. In the year 2002, what is the difference between the Aid flow (current US$) of Iran and Aid flow (current US$) of Saudi Arabia?
Your answer should be very brief. 3.81e+06. In the year 2002, what is the difference between the Aid flow (current US$) of Iran and Aid flow (current US$) of Tanzania?
Offer a terse response. -1.34e+08. In the year 2002, what is the difference between the Aid flow (current US$) of Saudi Arabia and Aid flow (current US$) of Tanzania?
Give a very brief answer. -1.38e+08. In the year 2004, what is the difference between the Aid flow (current US$) of Bangladesh and Aid flow (current US$) of Iran?
Your answer should be compact. 5.41e+07. In the year 2004, what is the difference between the Aid flow (current US$) of Bangladesh and Aid flow (current US$) of Saudi Arabia?
Your response must be concise. 6.52e+07. In the year 2004, what is the difference between the Aid flow (current US$) in Bangladesh and Aid flow (current US$) in Tanzania?
Ensure brevity in your answer.  -5.24e+07. In the year 2004, what is the difference between the Aid flow (current US$) in Iran and Aid flow (current US$) in Saudi Arabia?
Your answer should be very brief. 1.11e+07. In the year 2004, what is the difference between the Aid flow (current US$) of Iran and Aid flow (current US$) of Tanzania?
Your answer should be compact. -1.06e+08. In the year 2004, what is the difference between the Aid flow (current US$) of Saudi Arabia and Aid flow (current US$) of Tanzania?
Your answer should be compact. -1.18e+08. In the year 2005, what is the difference between the Aid flow (current US$) of Bangladesh and Aid flow (current US$) of Iran?
Ensure brevity in your answer.  5.39e+07. In the year 2005, what is the difference between the Aid flow (current US$) in Bangladesh and Aid flow (current US$) in Saudi Arabia?
Provide a succinct answer. 6.06e+07. In the year 2005, what is the difference between the Aid flow (current US$) in Bangladesh and Aid flow (current US$) in Tanzania?
Keep it short and to the point. -2.96e+07. In the year 2005, what is the difference between the Aid flow (current US$) of Iran and Aid flow (current US$) of Saudi Arabia?
Ensure brevity in your answer.  6.70e+06. In the year 2005, what is the difference between the Aid flow (current US$) of Iran and Aid flow (current US$) of Tanzania?
Your answer should be very brief. -8.35e+07. In the year 2005, what is the difference between the Aid flow (current US$) of Saudi Arabia and Aid flow (current US$) of Tanzania?
Provide a short and direct response. -9.02e+07. What is the ratio of the Aid flow (current US$) in Bangladesh in 1978 to that in 1979?
Your answer should be very brief. 1.39. What is the ratio of the Aid flow (current US$) of Saudi Arabia in 1978 to that in 1979?
Offer a terse response. 1. What is the ratio of the Aid flow (current US$) in Tanzania in 1978 to that in 1979?
Your answer should be very brief. 0.66. What is the ratio of the Aid flow (current US$) in Bangladesh in 1978 to that in 1980?
Your answer should be very brief. 1.2. What is the ratio of the Aid flow (current US$) of Saudi Arabia in 1978 to that in 1980?
Provide a succinct answer. 3.5. What is the ratio of the Aid flow (current US$) in Tanzania in 1978 to that in 1980?
Your answer should be very brief. 0.61. What is the ratio of the Aid flow (current US$) in Bangladesh in 1978 to that in 2000?
Provide a succinct answer. 1.95. What is the ratio of the Aid flow (current US$) in Iran in 1978 to that in 2000?
Provide a short and direct response. 1. What is the ratio of the Aid flow (current US$) in Saudi Arabia in 1978 to that in 2000?
Your response must be concise. 0.17. What is the ratio of the Aid flow (current US$) in Tanzania in 1978 to that in 2000?
Give a very brief answer. 0.52. What is the ratio of the Aid flow (current US$) in Bangladesh in 1978 to that in 2001?
Give a very brief answer. 1.47. What is the ratio of the Aid flow (current US$) of Iran in 1978 to that in 2001?
Your response must be concise. 0.02. What is the ratio of the Aid flow (current US$) of Saudi Arabia in 1978 to that in 2001?
Your response must be concise. 2.33. What is the ratio of the Aid flow (current US$) in Tanzania in 1978 to that in 2001?
Offer a very short reply. 0.68. What is the ratio of the Aid flow (current US$) of Bangladesh in 1978 to that in 2002?
Provide a succinct answer. 1.44. What is the ratio of the Aid flow (current US$) of Iran in 1978 to that in 2002?
Keep it short and to the point. 0.02. What is the ratio of the Aid flow (current US$) in Saudi Arabia in 1978 to that in 2002?
Provide a succinct answer. 7. What is the ratio of the Aid flow (current US$) of Tanzania in 1978 to that in 2002?
Your response must be concise. 0.37. What is the ratio of the Aid flow (current US$) in Bangladesh in 1978 to that in 2004?
Provide a short and direct response. 0.98. What is the ratio of the Aid flow (current US$) of Iran in 1978 to that in 2004?
Give a very brief answer. 0.01. What is the ratio of the Aid flow (current US$) of Saudi Arabia in 1978 to that in 2004?
Keep it short and to the point. 1. What is the ratio of the Aid flow (current US$) of Tanzania in 1978 to that in 2004?
Offer a very short reply. 0.43. What is the ratio of the Aid flow (current US$) of Bangladesh in 1978 to that in 2005?
Provide a succinct answer. 1.05. What is the ratio of the Aid flow (current US$) of Iran in 1978 to that in 2005?
Your answer should be very brief. 0.01. What is the ratio of the Aid flow (current US$) of Tanzania in 1978 to that in 2005?
Keep it short and to the point. 0.56. What is the ratio of the Aid flow (current US$) of Bangladesh in 1979 to that in 1980?
Your answer should be compact. 0.86. What is the ratio of the Aid flow (current US$) in Saudi Arabia in 1979 to that in 1980?
Provide a succinct answer. 3.5. What is the ratio of the Aid flow (current US$) in Tanzania in 1979 to that in 1980?
Offer a terse response. 0.93. What is the ratio of the Aid flow (current US$) of Bangladesh in 1979 to that in 2000?
Make the answer very short. 1.41. What is the ratio of the Aid flow (current US$) in Saudi Arabia in 1979 to that in 2000?
Your answer should be compact. 0.17. What is the ratio of the Aid flow (current US$) of Tanzania in 1979 to that in 2000?
Give a very brief answer. 0.8. What is the ratio of the Aid flow (current US$) in Bangladesh in 1979 to that in 2001?
Your answer should be very brief. 1.06. What is the ratio of the Aid flow (current US$) of Iran in 1979 to that in 2001?
Make the answer very short. 0.01. What is the ratio of the Aid flow (current US$) of Saudi Arabia in 1979 to that in 2001?
Ensure brevity in your answer.  2.33. What is the ratio of the Aid flow (current US$) in Tanzania in 1979 to that in 2001?
Your response must be concise. 1.03. What is the ratio of the Aid flow (current US$) in Bangladesh in 1979 to that in 2002?
Offer a very short reply. 1.03. What is the ratio of the Aid flow (current US$) of Iran in 1979 to that in 2002?
Your answer should be compact. 0.01. What is the ratio of the Aid flow (current US$) in Tanzania in 1979 to that in 2002?
Offer a very short reply. 0.56. What is the ratio of the Aid flow (current US$) of Bangladesh in 1979 to that in 2004?
Provide a short and direct response. 0.7. What is the ratio of the Aid flow (current US$) in Iran in 1979 to that in 2004?
Ensure brevity in your answer.  0. What is the ratio of the Aid flow (current US$) in Tanzania in 1979 to that in 2004?
Provide a succinct answer. 0.66. What is the ratio of the Aid flow (current US$) of Bangladesh in 1979 to that in 2005?
Give a very brief answer. 0.76. What is the ratio of the Aid flow (current US$) in Iran in 1979 to that in 2005?
Make the answer very short. 0.01. What is the ratio of the Aid flow (current US$) of Tanzania in 1979 to that in 2005?
Ensure brevity in your answer.  0.86. What is the ratio of the Aid flow (current US$) of Bangladesh in 1980 to that in 2000?
Provide a succinct answer. 1.63. What is the ratio of the Aid flow (current US$) of Iran in 1980 to that in 2000?
Keep it short and to the point. 0.14. What is the ratio of the Aid flow (current US$) in Saudi Arabia in 1980 to that in 2000?
Offer a very short reply. 0.05. What is the ratio of the Aid flow (current US$) of Tanzania in 1980 to that in 2000?
Provide a short and direct response. 0.85. What is the ratio of the Aid flow (current US$) in Bangladesh in 1980 to that in 2001?
Offer a terse response. 1.23. What is the ratio of the Aid flow (current US$) in Iran in 1980 to that in 2001?
Your response must be concise. 0. What is the ratio of the Aid flow (current US$) of Saudi Arabia in 1980 to that in 2001?
Provide a succinct answer. 0.67. What is the ratio of the Aid flow (current US$) in Tanzania in 1980 to that in 2001?
Offer a very short reply. 1.11. What is the ratio of the Aid flow (current US$) of Bangladesh in 1980 to that in 2002?
Keep it short and to the point. 1.2. What is the ratio of the Aid flow (current US$) in Iran in 1980 to that in 2002?
Your answer should be compact. 0. What is the ratio of the Aid flow (current US$) of Tanzania in 1980 to that in 2002?
Ensure brevity in your answer.  0.6. What is the ratio of the Aid flow (current US$) of Bangladesh in 1980 to that in 2004?
Make the answer very short. 0.81. What is the ratio of the Aid flow (current US$) of Iran in 1980 to that in 2004?
Keep it short and to the point. 0. What is the ratio of the Aid flow (current US$) of Saudi Arabia in 1980 to that in 2004?
Ensure brevity in your answer.  0.29. What is the ratio of the Aid flow (current US$) in Tanzania in 1980 to that in 2004?
Offer a very short reply. 0.71. What is the ratio of the Aid flow (current US$) in Bangladesh in 1980 to that in 2005?
Make the answer very short. 0.88. What is the ratio of the Aid flow (current US$) in Iran in 1980 to that in 2005?
Offer a very short reply. 0. What is the ratio of the Aid flow (current US$) of Tanzania in 1980 to that in 2005?
Ensure brevity in your answer.  0.92. What is the ratio of the Aid flow (current US$) of Bangladesh in 2000 to that in 2001?
Ensure brevity in your answer.  0.75. What is the ratio of the Aid flow (current US$) of Iran in 2000 to that in 2001?
Keep it short and to the point. 0.02. What is the ratio of the Aid flow (current US$) in Saudi Arabia in 2000 to that in 2001?
Make the answer very short. 13.67. What is the ratio of the Aid flow (current US$) of Tanzania in 2000 to that in 2001?
Make the answer very short. 1.3. What is the ratio of the Aid flow (current US$) in Bangladesh in 2000 to that in 2002?
Your answer should be very brief. 0.74. What is the ratio of the Aid flow (current US$) of Iran in 2000 to that in 2002?
Give a very brief answer. 0.02. What is the ratio of the Aid flow (current US$) in Saudi Arabia in 2000 to that in 2002?
Keep it short and to the point. 41. What is the ratio of the Aid flow (current US$) of Tanzania in 2000 to that in 2002?
Your response must be concise. 0.7. What is the ratio of the Aid flow (current US$) in Bangladesh in 2000 to that in 2004?
Your response must be concise. 0.5. What is the ratio of the Aid flow (current US$) in Iran in 2000 to that in 2004?
Ensure brevity in your answer.  0.01. What is the ratio of the Aid flow (current US$) in Saudi Arabia in 2000 to that in 2004?
Ensure brevity in your answer.  5.86. What is the ratio of the Aid flow (current US$) of Tanzania in 2000 to that in 2004?
Give a very brief answer. 0.83. What is the ratio of the Aid flow (current US$) in Bangladesh in 2000 to that in 2005?
Your answer should be compact. 0.54. What is the ratio of the Aid flow (current US$) of Iran in 2000 to that in 2005?
Keep it short and to the point. 0.01. What is the ratio of the Aid flow (current US$) of Tanzania in 2000 to that in 2005?
Offer a very short reply. 1.08. What is the ratio of the Aid flow (current US$) of Bangladesh in 2001 to that in 2002?
Your answer should be compact. 0.98. What is the ratio of the Aid flow (current US$) of Iran in 2001 to that in 2002?
Keep it short and to the point. 0.99. What is the ratio of the Aid flow (current US$) in Tanzania in 2001 to that in 2002?
Offer a very short reply. 0.54. What is the ratio of the Aid flow (current US$) of Bangladesh in 2001 to that in 2004?
Offer a very short reply. 0.66. What is the ratio of the Aid flow (current US$) in Iran in 2001 to that in 2004?
Your answer should be compact. 0.34. What is the ratio of the Aid flow (current US$) of Saudi Arabia in 2001 to that in 2004?
Offer a very short reply. 0.43. What is the ratio of the Aid flow (current US$) in Tanzania in 2001 to that in 2004?
Provide a short and direct response. 0.64. What is the ratio of the Aid flow (current US$) in Bangladesh in 2001 to that in 2005?
Keep it short and to the point. 0.71. What is the ratio of the Aid flow (current US$) of Iran in 2001 to that in 2005?
Keep it short and to the point. 0.56. What is the ratio of the Aid flow (current US$) in Tanzania in 2001 to that in 2005?
Your response must be concise. 0.83. What is the ratio of the Aid flow (current US$) of Bangladesh in 2002 to that in 2004?
Your response must be concise. 0.68. What is the ratio of the Aid flow (current US$) in Iran in 2002 to that in 2004?
Provide a succinct answer. 0.34. What is the ratio of the Aid flow (current US$) of Saudi Arabia in 2002 to that in 2004?
Ensure brevity in your answer.  0.14. What is the ratio of the Aid flow (current US$) of Tanzania in 2002 to that in 2004?
Give a very brief answer. 1.18. What is the ratio of the Aid flow (current US$) in Bangladesh in 2002 to that in 2005?
Offer a very short reply. 0.73. What is the ratio of the Aid flow (current US$) of Iran in 2002 to that in 2005?
Your answer should be very brief. 0.57. What is the ratio of the Aid flow (current US$) of Saudi Arabia in 2002 to that in 2005?
Offer a very short reply. 0.2. What is the ratio of the Aid flow (current US$) of Tanzania in 2002 to that in 2005?
Provide a succinct answer. 1.53. What is the ratio of the Aid flow (current US$) of Bangladesh in 2004 to that in 2005?
Provide a succinct answer. 1.07. What is the ratio of the Aid flow (current US$) of Iran in 2004 to that in 2005?
Give a very brief answer. 1.65. What is the ratio of the Aid flow (current US$) of Saudi Arabia in 2004 to that in 2005?
Your answer should be very brief. 1.4. What is the ratio of the Aid flow (current US$) of Tanzania in 2004 to that in 2005?
Offer a very short reply. 1.3. What is the difference between the highest and the second highest Aid flow (current US$) in Bangladesh?
Offer a very short reply. 1.62e+06. What is the difference between the highest and the second highest Aid flow (current US$) of Iran?
Offer a terse response. 4.38e+06. What is the difference between the highest and the second highest Aid flow (current US$) in Saudi Arabia?
Offer a very short reply. 3.40e+05. What is the difference between the highest and the second highest Aid flow (current US$) in Tanzania?
Keep it short and to the point. 2.07e+07. What is the difference between the highest and the lowest Aid flow (current US$) of Bangladesh?
Provide a short and direct response. 3.26e+07. What is the difference between the highest and the lowest Aid flow (current US$) of Iran?
Offer a very short reply. 1.11e+07. What is the difference between the highest and the lowest Aid flow (current US$) of Saudi Arabia?
Ensure brevity in your answer.  4.00e+05. What is the difference between the highest and the lowest Aid flow (current US$) of Tanzania?
Your response must be concise. 8.74e+07. 